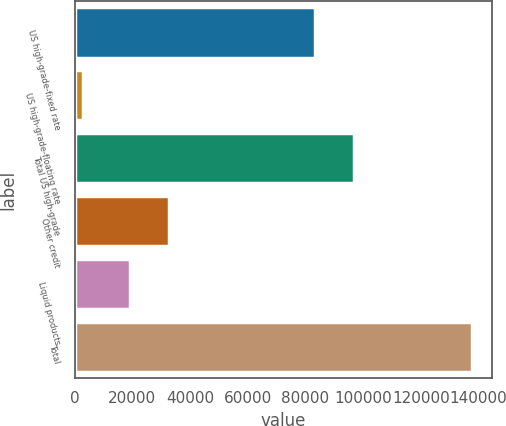Convert chart. <chart><loc_0><loc_0><loc_500><loc_500><bar_chart><fcel>US high-grade-fixed rate<fcel>US high-grade-floating rate<fcel>Total US high-grade<fcel>Other credit<fcel>Liquid products<fcel>Total<nl><fcel>83193<fcel>2795<fcel>96688.7<fcel>32652.7<fcel>19157<fcel>137752<nl></chart> 